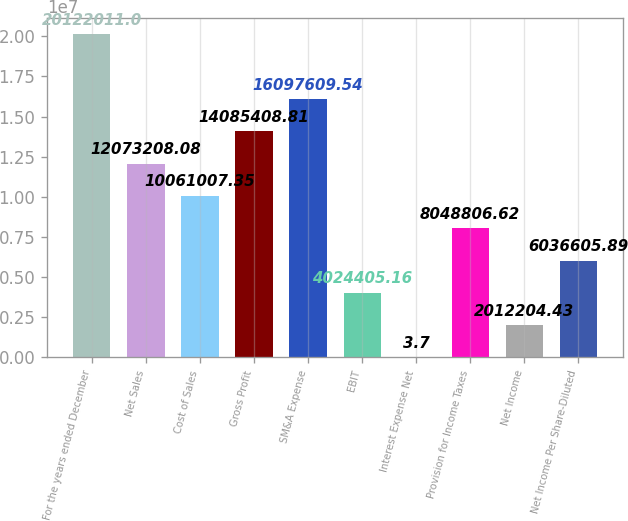<chart> <loc_0><loc_0><loc_500><loc_500><bar_chart><fcel>For the years ended December<fcel>Net Sales<fcel>Cost of Sales<fcel>Gross Profit<fcel>SM&A Expense<fcel>EBIT<fcel>Interest Expense Net<fcel>Provision for Income Taxes<fcel>Net Income<fcel>Net Income Per Share-Diluted<nl><fcel>2.0122e+07<fcel>1.20732e+07<fcel>1.0061e+07<fcel>1.40854e+07<fcel>1.60976e+07<fcel>4.02441e+06<fcel>3.7<fcel>8.04881e+06<fcel>2.0122e+06<fcel>6.03661e+06<nl></chart> 